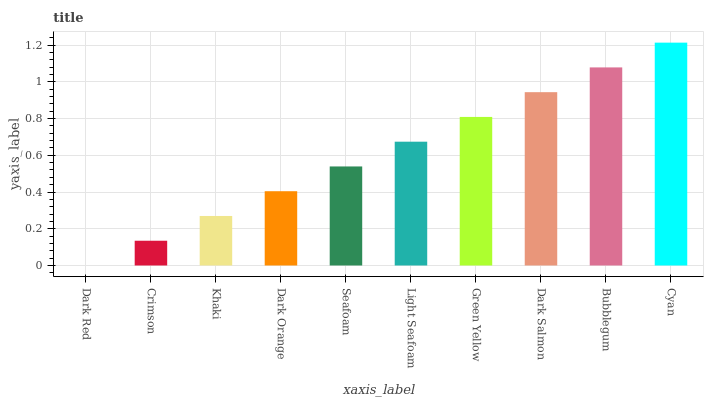Is Dark Red the minimum?
Answer yes or no. Yes. Is Cyan the maximum?
Answer yes or no. Yes. Is Crimson the minimum?
Answer yes or no. No. Is Crimson the maximum?
Answer yes or no. No. Is Crimson greater than Dark Red?
Answer yes or no. Yes. Is Dark Red less than Crimson?
Answer yes or no. Yes. Is Dark Red greater than Crimson?
Answer yes or no. No. Is Crimson less than Dark Red?
Answer yes or no. No. Is Light Seafoam the high median?
Answer yes or no. Yes. Is Seafoam the low median?
Answer yes or no. Yes. Is Bubblegum the high median?
Answer yes or no. No. Is Bubblegum the low median?
Answer yes or no. No. 